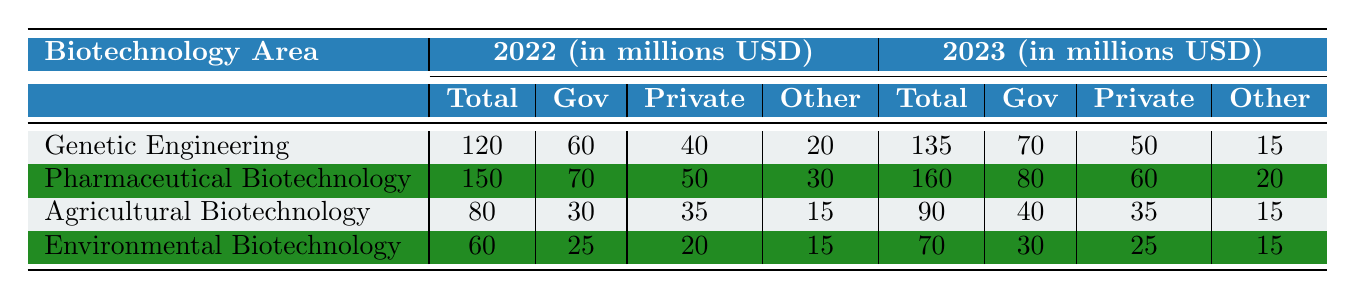What is the total funding for Agricultural Biotechnology in 2023? The table shows that the total funding for Agricultural Biotechnology in 2023 is listed under the 2023 column as 90 million USD.
Answer: 90 million USD How much government funding was allocated to Environmental Biotechnology in 2022? In the table, the government funding for Environmental Biotechnology in 2022 is shown as 25 million USD.
Answer: 25 million USD What was the increase in total funding for Genetic Engineering from 2022 to 2023? The total funding for Genetic Engineering in 2022 was 120 million USD and in 2023 it is 135 million USD. The increase can be calculated as 135 - 120 = 15 million USD.
Answer: 15 million USD Which biotechnology area received the highest total funding in 2023? The total funding amounts for each area in 2023 are 135 million (Genetic Engineering), 160 million (Pharmaceutical Biotechnology), 90 million (Agricultural Biotechnology), and 70 million (Environmental Biotechnology). The highest is 160 million for Pharmaceutical Biotechnology.
Answer: Pharmaceutical Biotechnology What percentage of the total funding for Pharmaceutical Biotechnology in 2023 came from government sources? The total funding for Pharmaceutical Biotechnology in 2023 is 160 million USD, with government funding of 80 million USD. The percentage can be calculated as (80/160) * 100 = 50%.
Answer: 50% Was the total funding for Environmental Biotechnology higher in 2022 or 2023? The total funding for Environmental Biotechnology in 2022 is 60 million USD and in 2023 it is 70 million USD. Comparing the two shows that 70 million USD is higher than 60 million USD.
Answer: Higher in 2023 What is the average total funding for all biotechnology areas in 2022? To find the average, sum the total funding for 2022: 120 + 150 + 80 + 60 = 410 million USD. Dividing by the number of areas (4) gives an average of 410 / 4 = 102.5 million USD.
Answer: 102.5 million USD Which area saw the least amount of funding from the private sector in 2023? In 2023, the private sector funding for each area is: Genetic Engineering (50 million), Pharmaceutical Biotechnology (60 million), Agricultural Biotechnology (35 million), and Environmental Biotechnology (25 million). Environmental Biotechnology has the least at 25 million.
Answer: Environmental Biotechnology What is the total “Other” funding across all biotechnology areas for 2022? The "Other" funding for 2022 can be summed as follows: Genetic Engineering (20 million) + Pharmaceutical Biotechnology (30 million) + Agricultural Biotechnology (15 million) + Environmental Biotechnology (15 million) = 80 million USD.
Answer: 80 million USD Did the total funding for Agricultural Biotechnology increase or decrease from 2022 to 2023? Agricultural Biotechnology had total funding of 80 million USD in 2022 and 90 million USD in 2023, indicating an increase from 80 to 90 million USD.
Answer: Increase 